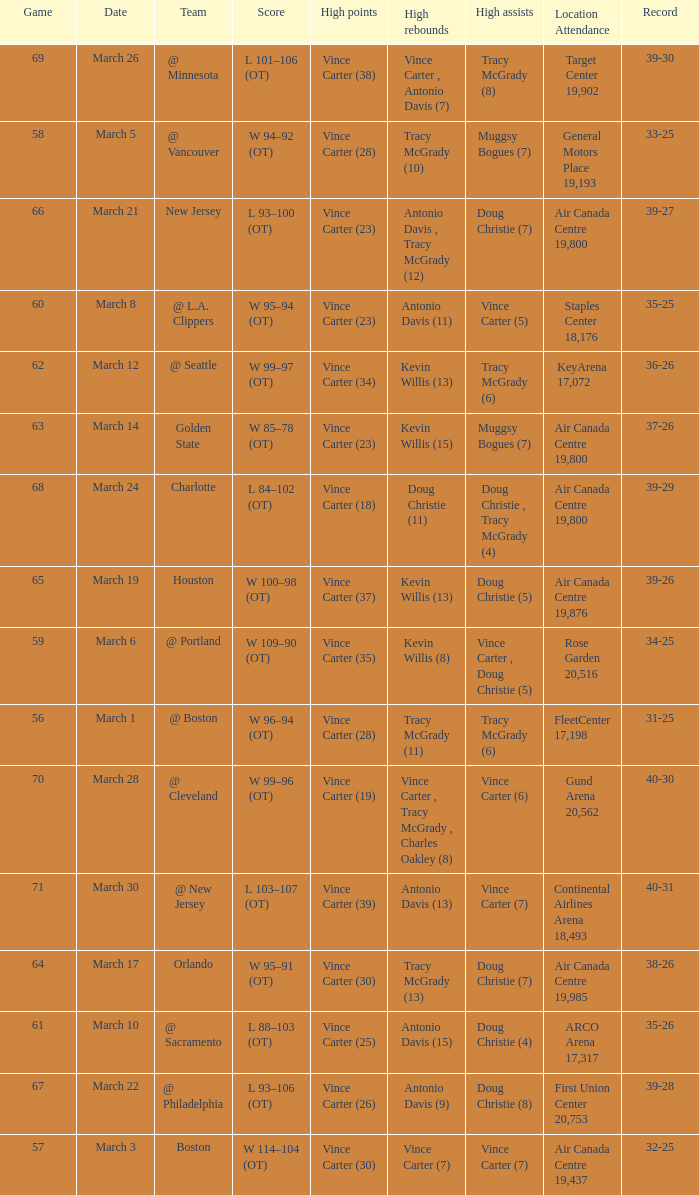How many people had the high assists @ minnesota? 1.0. 